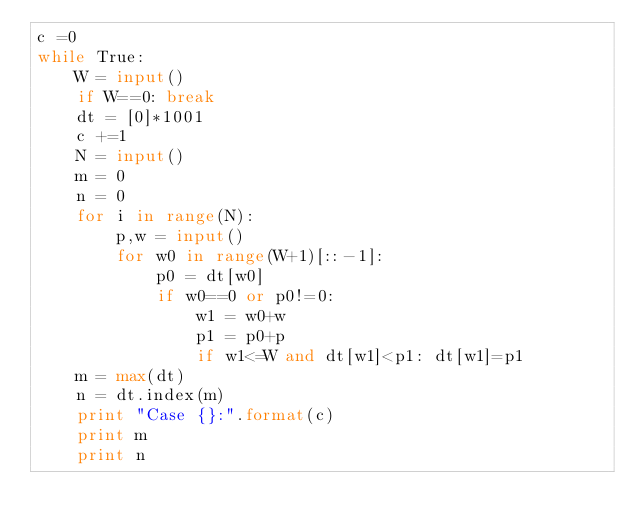Convert code to text. <code><loc_0><loc_0><loc_500><loc_500><_Python_>c =0
while True:
    W = input()
    if W==0: break
    dt = [0]*1001
    c +=1
    N = input()
    m = 0
    n = 0
    for i in range(N):
        p,w = input()
        for w0 in range(W+1)[::-1]:
            p0 = dt[w0]
            if w0==0 or p0!=0:
                w1 = w0+w
                p1 = p0+p
                if w1<=W and dt[w1]<p1: dt[w1]=p1
    m = max(dt)
    n = dt.index(m)
    print "Case {}:".format(c)
    print m
    print n</code> 